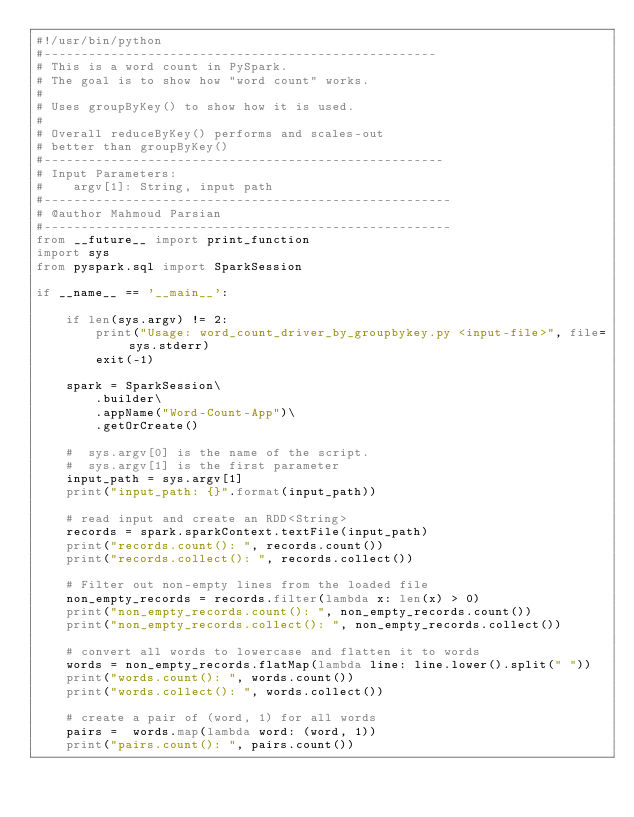Convert code to text. <code><loc_0><loc_0><loc_500><loc_500><_Python_>#!/usr/bin/python
#-----------------------------------------------------
# This is a word count in PySpark.
# The goal is to show how "word count" works.
#
# Uses groupByKey() to show how it is used.
#
# Overall reduceByKey() performs and scales-out 
# better than groupByKey()
#------------------------------------------------------
# Input Parameters:
#    argv[1]: String, input path
#-------------------------------------------------------
# @author Mahmoud Parsian
#-------------------------------------------------------
from __future__ import print_function 
import sys 
from pyspark.sql import SparkSession 

if __name__ == '__main__':

    if len(sys.argv) != 2:  
        print("Usage: word_count_driver_by_groupbykey.py <input-file>", file=sys.stderr)
        exit(-1)

    spark = SparkSession\
        .builder\
        .appName("Word-Count-App")\
        .getOrCreate()

    #  sys.argv[0] is the name of the script.
    #  sys.argv[1] is the first parameter
    input_path = sys.argv[1]  
    print("input_path: {}".format(input_path))

    # read input and create an RDD<String>
    records = spark.sparkContext.textFile(input_path) 
    print("records.count(): ", records.count())
    print("records.collect(): ", records.collect())
    
    # Filter out non-empty lines from the loaded file 
    non_empty_records = records.filter(lambda x: len(x) > 0)
    print("non_empty_records.count(): ", non_empty_records.count())
    print("non_empty_records.collect(): ", non_empty_records.collect())

    # convert all words to lowercase and flatten it to words
    words = non_empty_records.flatMap(lambda line: line.lower().split(" ")) 
    print("words.count(): ", words.count())
    print("words.collect(): ", words.collect())

    # create a pair of (word, 1) for all words
    pairs =  words.map(lambda word: (word, 1)) 
    print("pairs.count(): ", pairs.count())</code> 